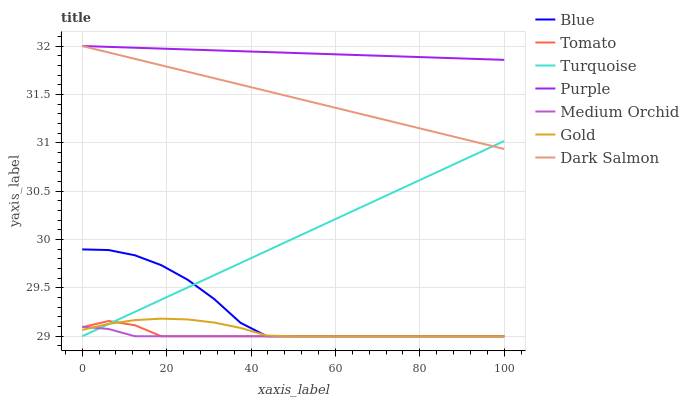Does Medium Orchid have the minimum area under the curve?
Answer yes or no. Yes. Does Purple have the maximum area under the curve?
Answer yes or no. Yes. Does Tomato have the minimum area under the curve?
Answer yes or no. No. Does Tomato have the maximum area under the curve?
Answer yes or no. No. Is Dark Salmon the smoothest?
Answer yes or no. Yes. Is Blue the roughest?
Answer yes or no. Yes. Is Tomato the smoothest?
Answer yes or no. No. Is Tomato the roughest?
Answer yes or no. No. Does Purple have the lowest value?
Answer yes or no. No. Does Dark Salmon have the highest value?
Answer yes or no. Yes. Does Tomato have the highest value?
Answer yes or no. No. Is Blue less than Purple?
Answer yes or no. Yes. Is Purple greater than Medium Orchid?
Answer yes or no. Yes. Does Tomato intersect Gold?
Answer yes or no. Yes. Is Tomato less than Gold?
Answer yes or no. No. Is Tomato greater than Gold?
Answer yes or no. No. Does Blue intersect Purple?
Answer yes or no. No. 